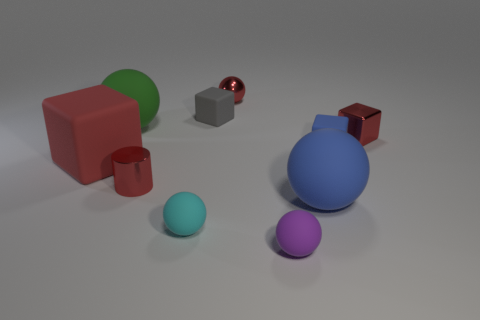Subtract all blue rubber spheres. How many spheres are left? 4 Subtract 1 cylinders. How many cylinders are left? 0 Subtract all gray blocks. How many blocks are left? 3 Subtract all blue cylinders. How many brown spheres are left? 0 Subtract all gray cubes. Subtract all purple balls. How many objects are left? 8 Add 7 small cyan rubber things. How many small cyan rubber things are left? 8 Add 6 red rubber cubes. How many red rubber cubes exist? 7 Subtract 0 blue cylinders. How many objects are left? 10 Subtract all cylinders. How many objects are left? 9 Subtract all cyan cubes. Subtract all green cylinders. How many cubes are left? 4 